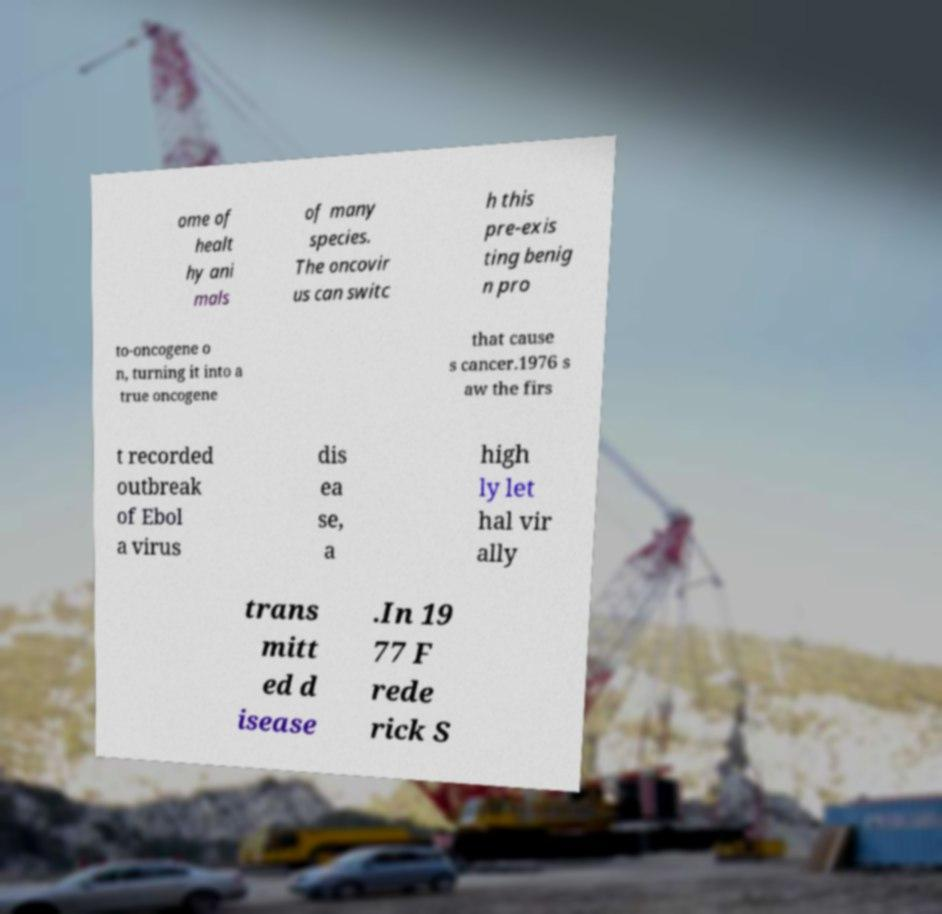Please read and relay the text visible in this image. What does it say? ome of healt hy ani mals of many species. The oncovir us can switc h this pre-exis ting benig n pro to-oncogene o n, turning it into a true oncogene that cause s cancer.1976 s aw the firs t recorded outbreak of Ebol a virus dis ea se, a high ly let hal vir ally trans mitt ed d isease .In 19 77 F rede rick S 